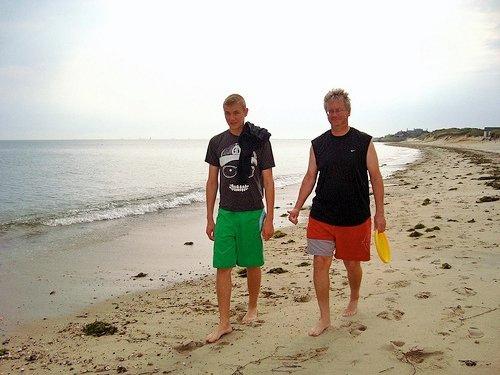What does the man's shirt say?
Concise answer only. Nothing. What are the people carrying?
Answer briefly. Frisbee. What is the man holding?
Quick response, please. Frisbee. Does the man have on a shirt?
Give a very brief answer. Yes. What are these people standing next to?
Quick response, please. Ocean. What direction are the men facing?
Keep it brief. South. Is the water still?
Quick response, please. No. What is he holding in his hands?
Keep it brief. Frisbee. Are the going to go surfing?
Short answer required. No. What are the men walking through?
Be succinct. Sand. Is it windy?
Quick response, please. No. What sport did they just finish?
Short answer required. Frisbee. Is one of the people drinking a beer?
Be succinct. No. Are the men near a body of water?
Keep it brief. Yes. 